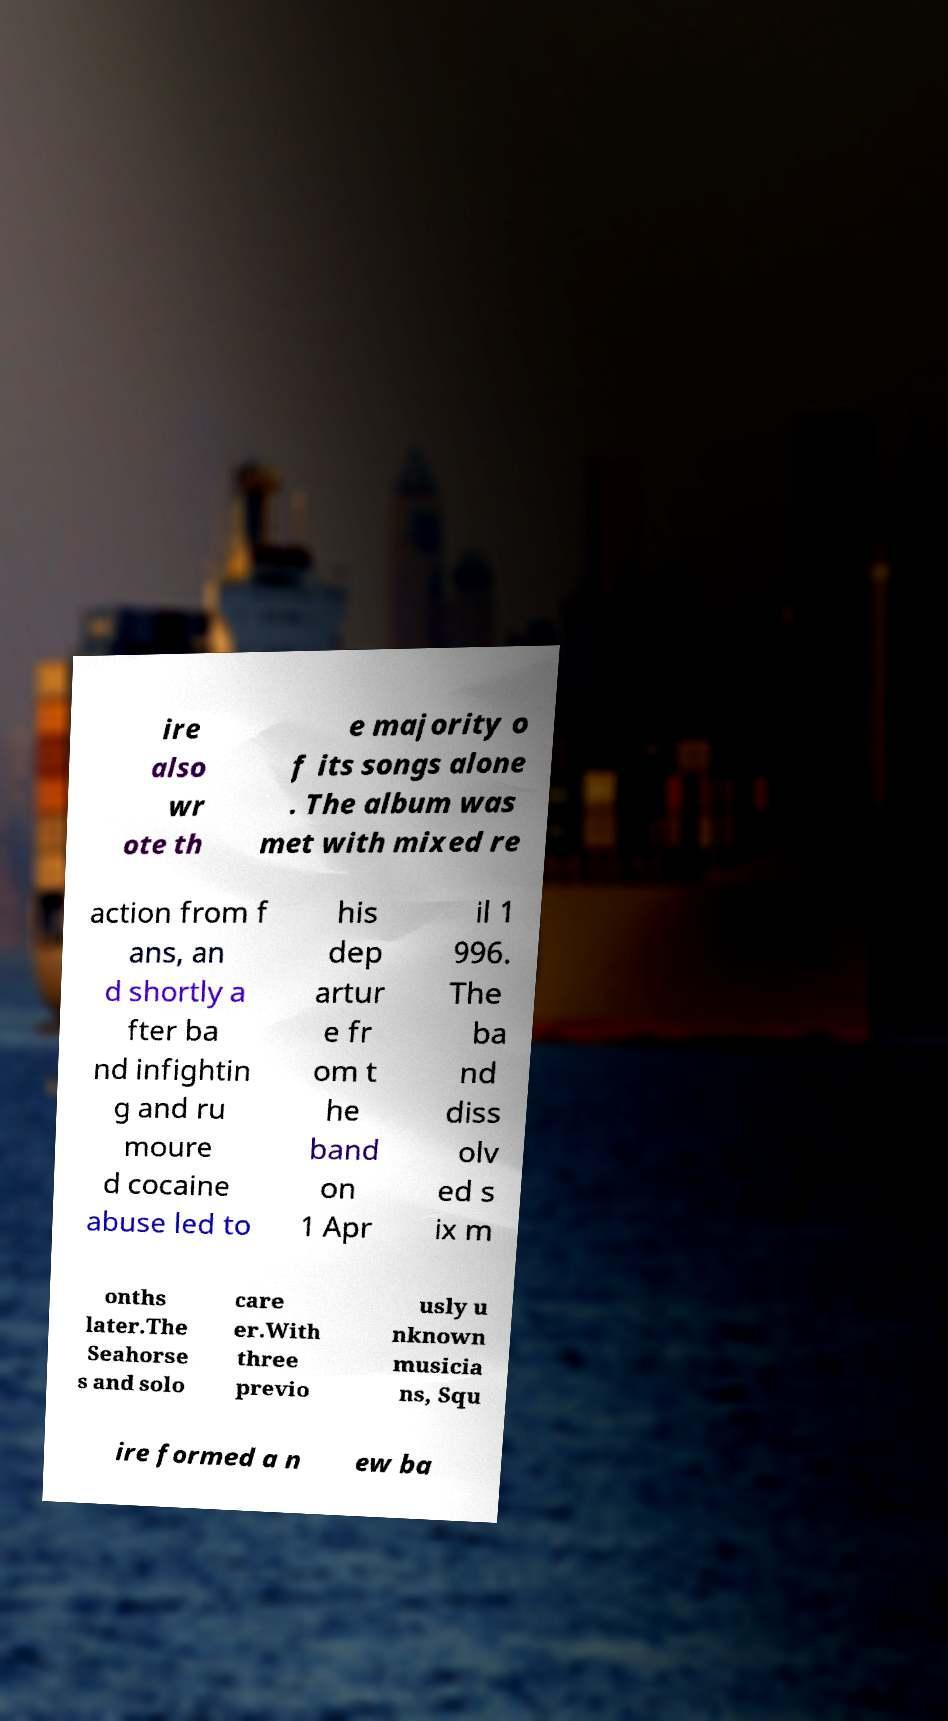What messages or text are displayed in this image? I need them in a readable, typed format. ire also wr ote th e majority o f its songs alone . The album was met with mixed re action from f ans, an d shortly a fter ba nd infightin g and ru moure d cocaine abuse led to his dep artur e fr om t he band on 1 Apr il 1 996. The ba nd diss olv ed s ix m onths later.The Seahorse s and solo care er.With three previo usly u nknown musicia ns, Squ ire formed a n ew ba 